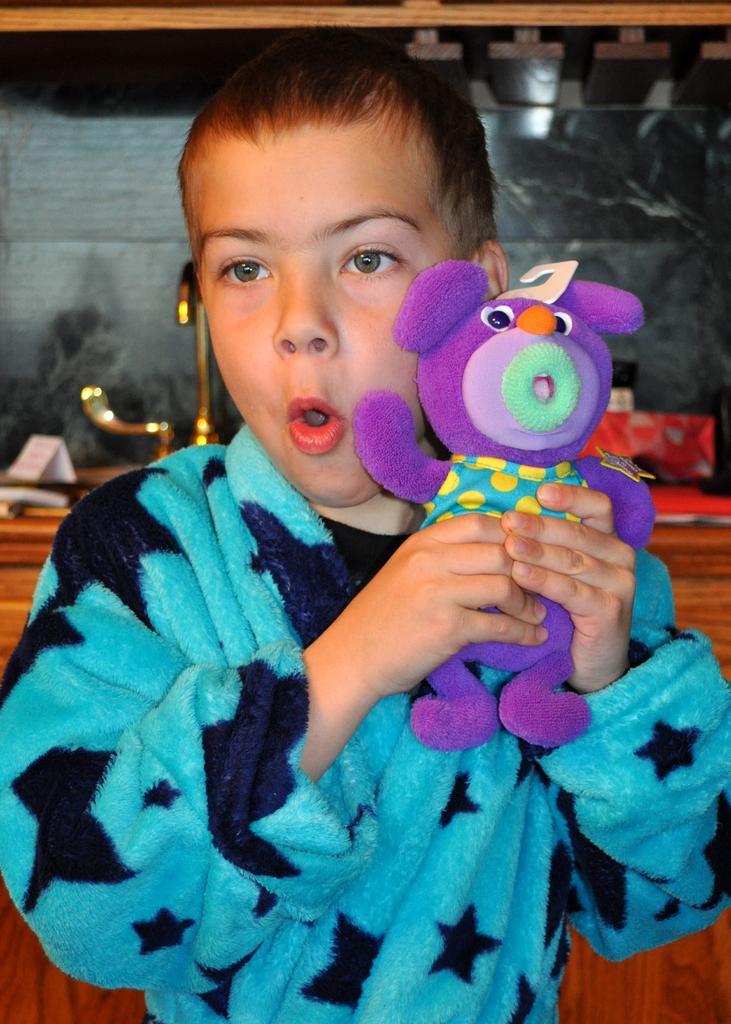Can you describe this image briefly? In this image there is a kid holding a toy in his hands, in the background there is a wooden table, on that there are few items. 